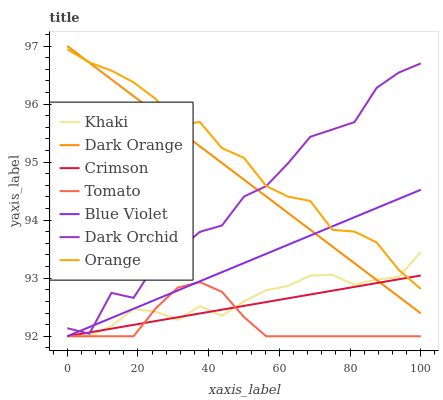Does Tomato have the minimum area under the curve?
Answer yes or no. Yes. Does Orange have the maximum area under the curve?
Answer yes or no. Yes. Does Dark Orange have the minimum area under the curve?
Answer yes or no. No. Does Dark Orange have the maximum area under the curve?
Answer yes or no. No. Is Crimson the smoothest?
Answer yes or no. Yes. Is Dark Orchid the roughest?
Answer yes or no. Yes. Is Dark Orange the smoothest?
Answer yes or no. No. Is Dark Orange the roughest?
Answer yes or no. No. Does Tomato have the lowest value?
Answer yes or no. Yes. Does Dark Orange have the lowest value?
Answer yes or no. No. Does Dark Orange have the highest value?
Answer yes or no. Yes. Does Khaki have the highest value?
Answer yes or no. No. Is Tomato less than Orange?
Answer yes or no. Yes. Is Dark Orchid greater than Khaki?
Answer yes or no. Yes. Does Crimson intersect Dark Orchid?
Answer yes or no. Yes. Is Crimson less than Dark Orchid?
Answer yes or no. No. Is Crimson greater than Dark Orchid?
Answer yes or no. No. Does Tomato intersect Orange?
Answer yes or no. No. 